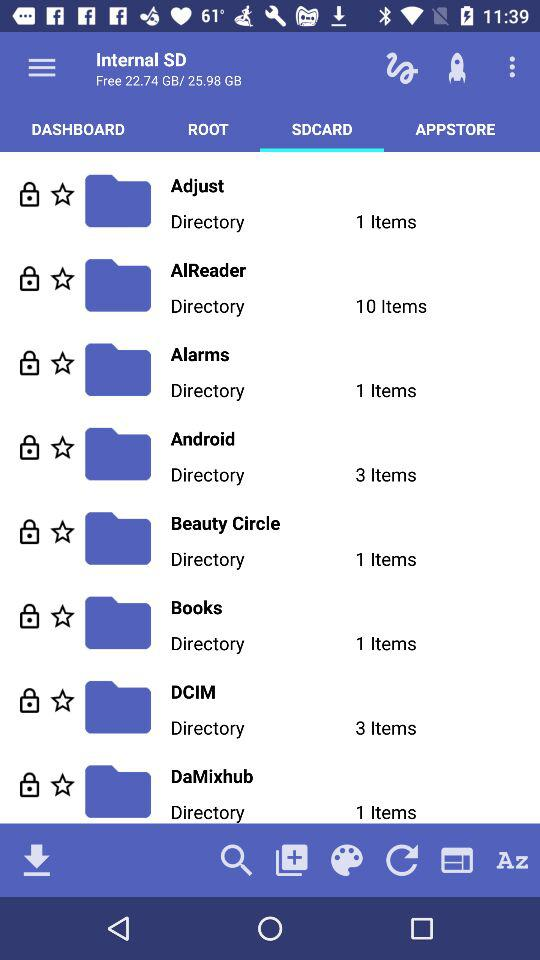What is the number of items in the beauty circle? The number of items in the beauty circle is 1. 